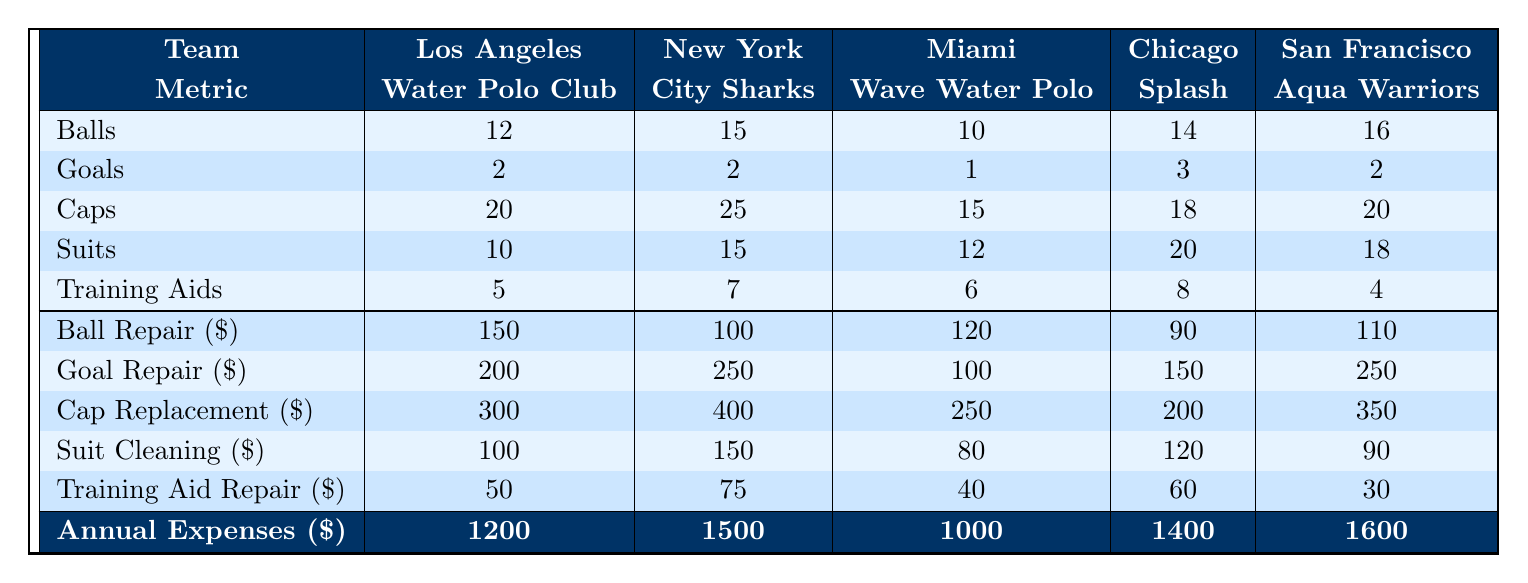What is the total number of balls used by all teams combined? To find the total, add the number of balls from each team: 12 (LA) + 15 (NYC) + 10 (Miami) + 14 (Chicago) + 16 (SF) = 67.
Answer: 67 Which team has the highest annual expenses? Looking at the annual expenses row, San Francisco Aqua Warriors has the highest value at 1600.
Answer: San Francisco Aqua Warriors How many caps does the New York City Sharks team have? Referencing the caps row, New York City Sharks has 25 caps listed.
Answer: 25 What is the total cost of ball and goal repairs for the Los Angeles Water Polo Club? For Los Angeles, ball repair cost is 150 and goal repair cost is 200. Add these: 150 + 200 = 350.
Answer: 350 Which team has the least number of training aids? By checking the training aids row, San Francisco Aqua Warriors has the lowest number at 4.
Answer: San Francisco Aqua Warriors What is the average cap replacement cost across the teams? Add the cap replacement costs: 300 (LA) + 400 (NYC) + 250 (Miami) + 200 (Chicago) + 350 (SF) = 1500, then divide by 5: 1500 / 5 = 300.
Answer: 300 Are Miami Wave Water Polo's annual expenses less than Chicago Splash's? Miami's expenses are 1000 and Chicago's are 1400. Since 1000 is less than 1400, the answer is yes.
Answer: Yes What is the difference in the number of suits between the New York City Sharks and Miami Wave Water Polo? New York City Sharks has 15 suits and Miami has 12 suits. The difference is 15 - 12 = 3.
Answer: 3 What team has the least number of goals, and how many goals do they have? In the goals row, Miami Wave Water Polo has the least with just 1 goal.
Answer: Miami Wave Water Polo, 1 goal What is the total maintenance cost for the Chicago Splash team? Adding up their repair costs: 90 (ball) + 150 (goal) + 200 (cap) + 120 (suit) + 60 (training aid) gives: 90 + 150 + 200 + 120 + 60 = 620.
Answer: 620 